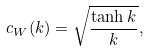Convert formula to latex. <formula><loc_0><loc_0><loc_500><loc_500>c _ { W } ( k ) = \sqrt { \frac { \tanh k } { k } } ,</formula> 